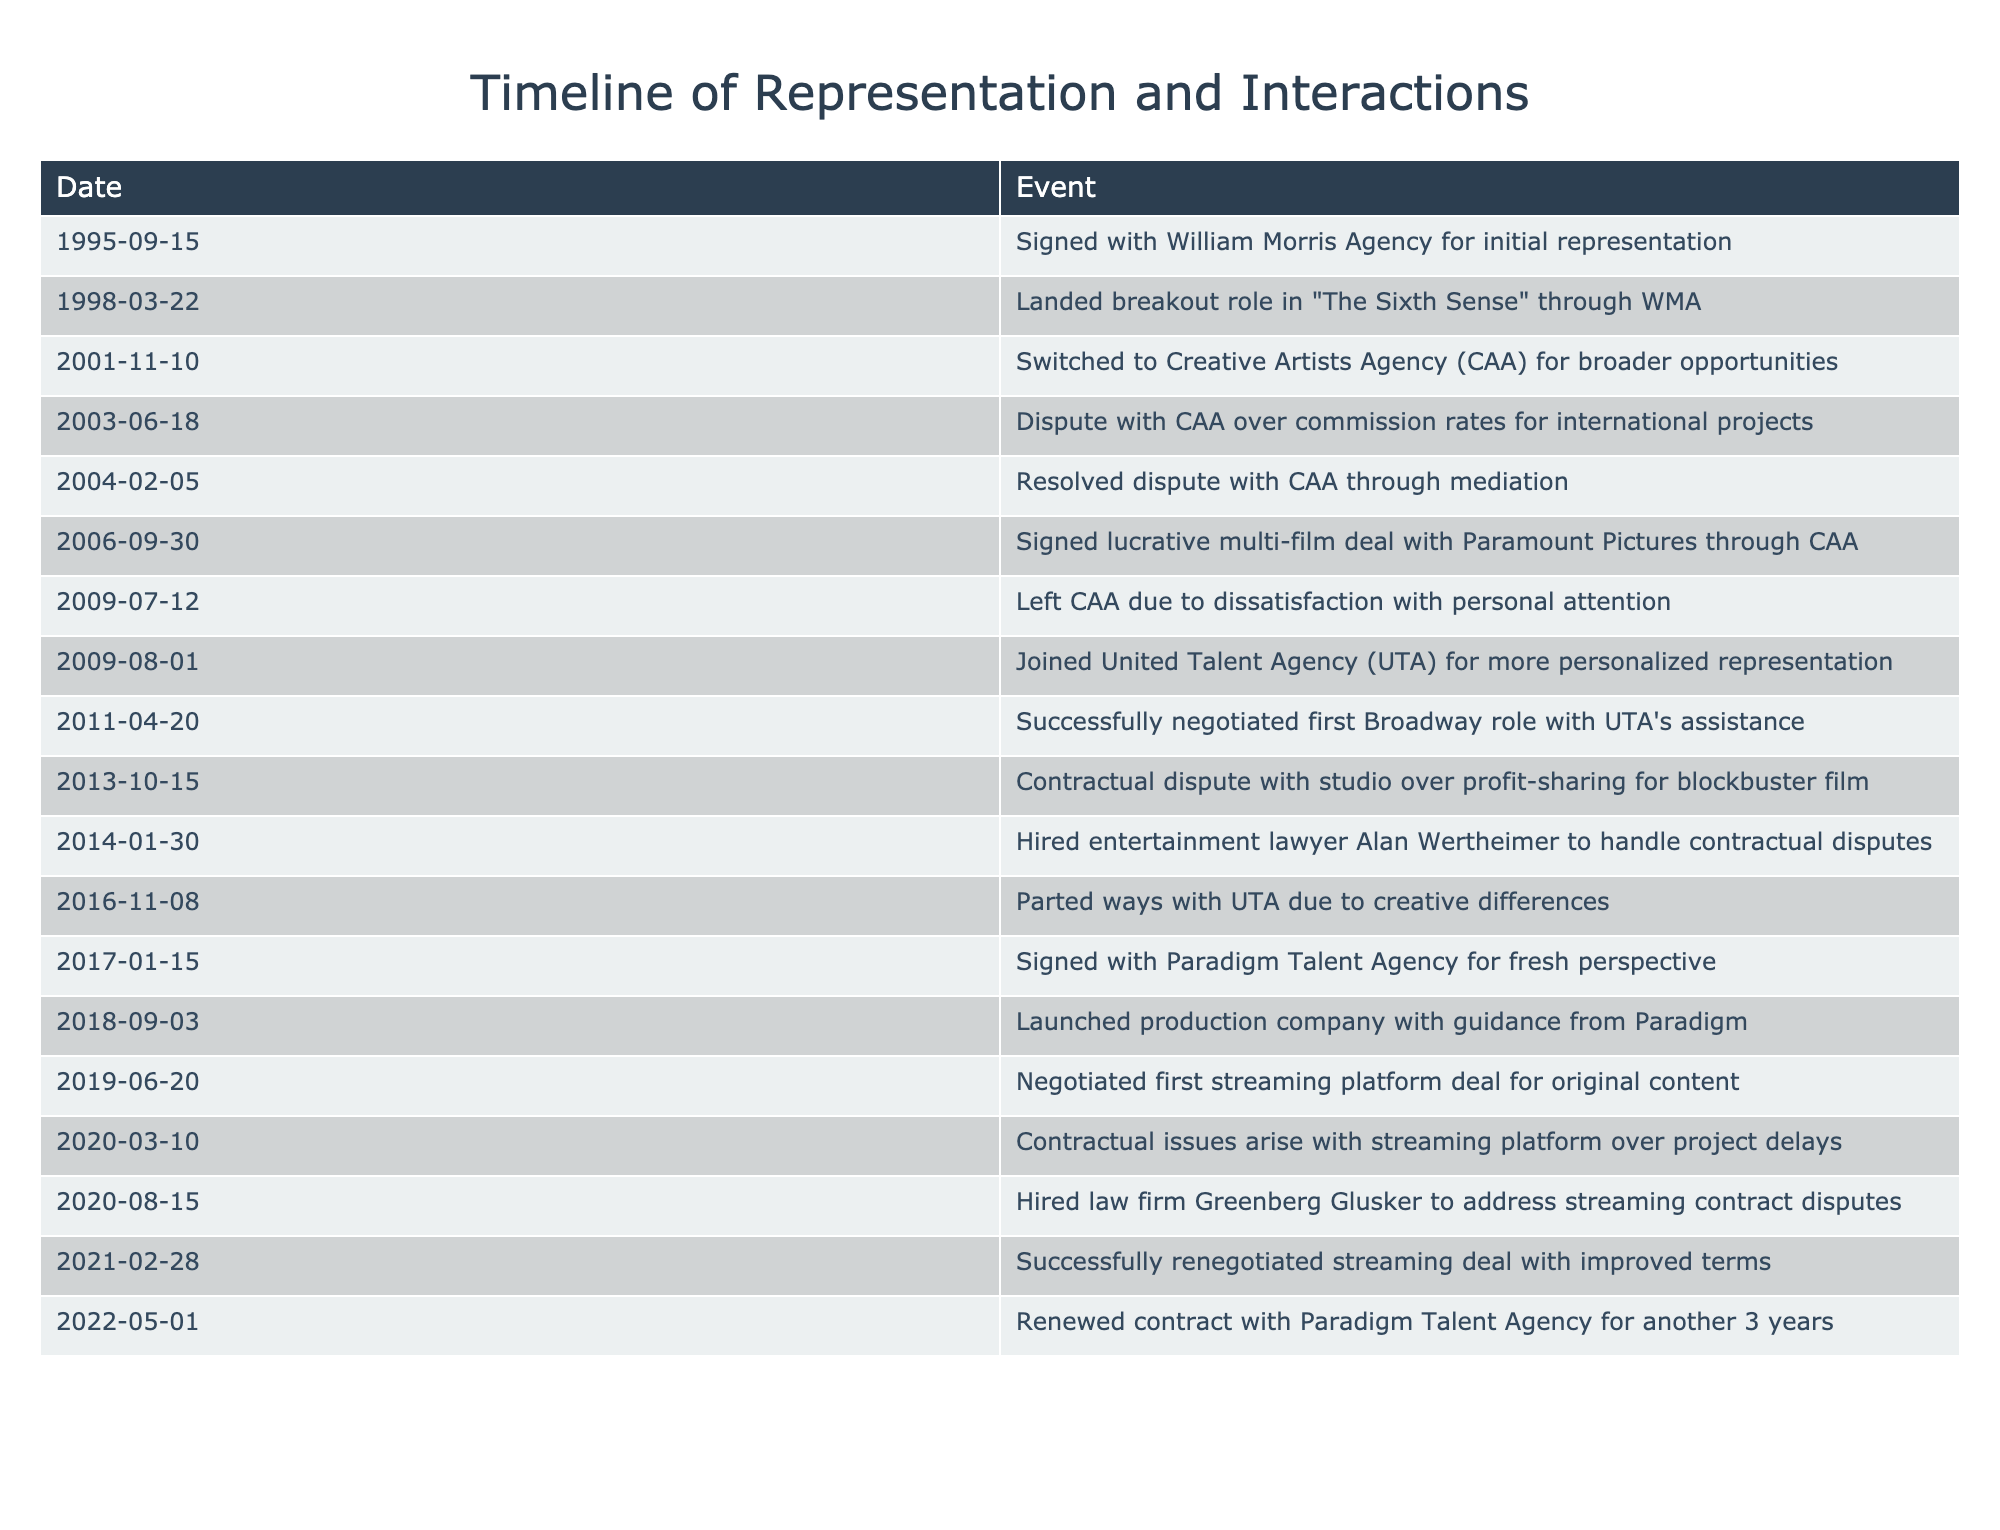What date did I sign with William Morris Agency? The timeline indicates that I signed with William Morris Agency on September 15, 1995.
Answer: September 15, 1995 What event happened just after I landed my breakout role? The event that occurred just after landing my breakout role in "The Sixth Sense" was switching to Creative Artists Agency on November 10, 2001. Both events are recorded consecutively in the timeline.
Answer: Switched to Creative Artists Agency on November 10, 2001 How many talent agencies have I been represented by according to the timeline? The timeline shows I have been represented by four agencies: William Morris Agency, Creative Artists Agency, United Talent Agency, and Paradigm Talent Agency. By counting each unique agency listed, the total is four.
Answer: Four Was there a dispute with any talent agency? Yes, there was a dispute with Creative Artists Agency over commission rates for international projects recorded on June 18, 2003.
Answer: Yes What was the time between my first negotiation with UTA and the first contractual dispute mentioned? I successfully negotiated my first Broadway role with UTA on April 20, 2011, and the first contractual dispute with a studio occurred on October 15, 2013. The time between these two events is 2 years and about 5 months.
Answer: 2 years and about 5 months What percentage of my talent representation interactions involved disputes? There were four representations mentioned: I had two disputes (with CAA and later with a studio). This gives us a percentage of 2 out of 4, which is 50%.
Answer: 50% What action did I take after feeling dissatisfaction with CAA? After feeling dissatisfaction with CAA, I left the agency on July 12, 2009, and subsequently joined United Talent Agency on August 1, 2009. This is a logical action after a negative experience.
Answer: Left CAA and joined UTA Did I ever hire a lawyer, and if so, when? Yes, I hired entertainment lawyer Alan Wertheimer on January 30, 2014, to handle contractual disputes. The table explicitly states this event.
Answer: Yes, on January 30, 2014 What major deal did I negotiate in 2021? In 2021, I successfully renegotiated a streaming deal with improved terms on February 28. This timing shows a significant achievement in the context of my negotiations.
Answer: Successfully renegotiated streaming deal on February 28, 2021 